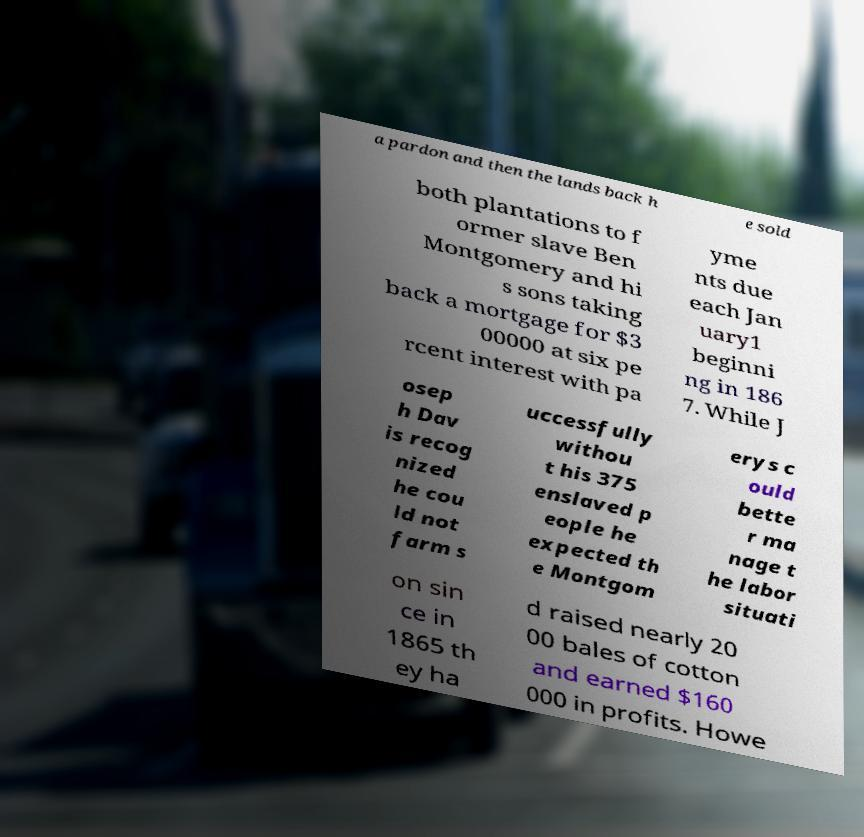Can you accurately transcribe the text from the provided image for me? a pardon and then the lands back h e sold both plantations to f ormer slave Ben Montgomery and hi s sons taking back a mortgage for $3 00000 at six pe rcent interest with pa yme nts due each Jan uary1 beginni ng in 186 7. While J osep h Dav is recog nized he cou ld not farm s uccessfully withou t his 375 enslaved p eople he expected th e Montgom erys c ould bette r ma nage t he labor situati on sin ce in 1865 th ey ha d raised nearly 20 00 bales of cotton and earned $160 000 in profits. Howe 